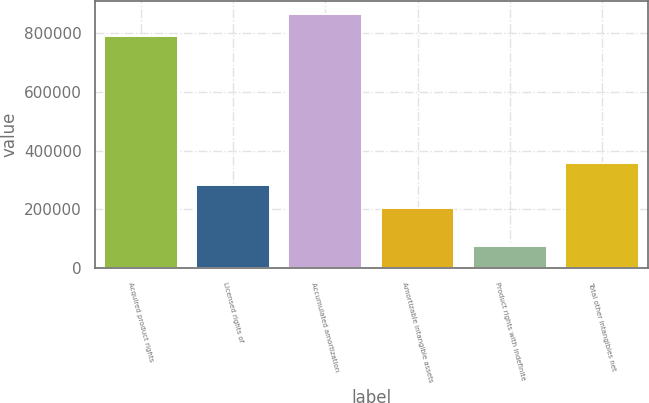Convert chart. <chart><loc_0><loc_0><loc_500><loc_500><bar_chart><fcel>Acquired product rights<fcel>Licensed rights of<fcel>Accumulated amortization<fcel>Amortizable intangible assets<fcel>Product rights with indefinite<fcel>Total other intangibles net<nl><fcel>789781<fcel>281622<fcel>866334<fcel>205069<fcel>75738<fcel>358175<nl></chart> 